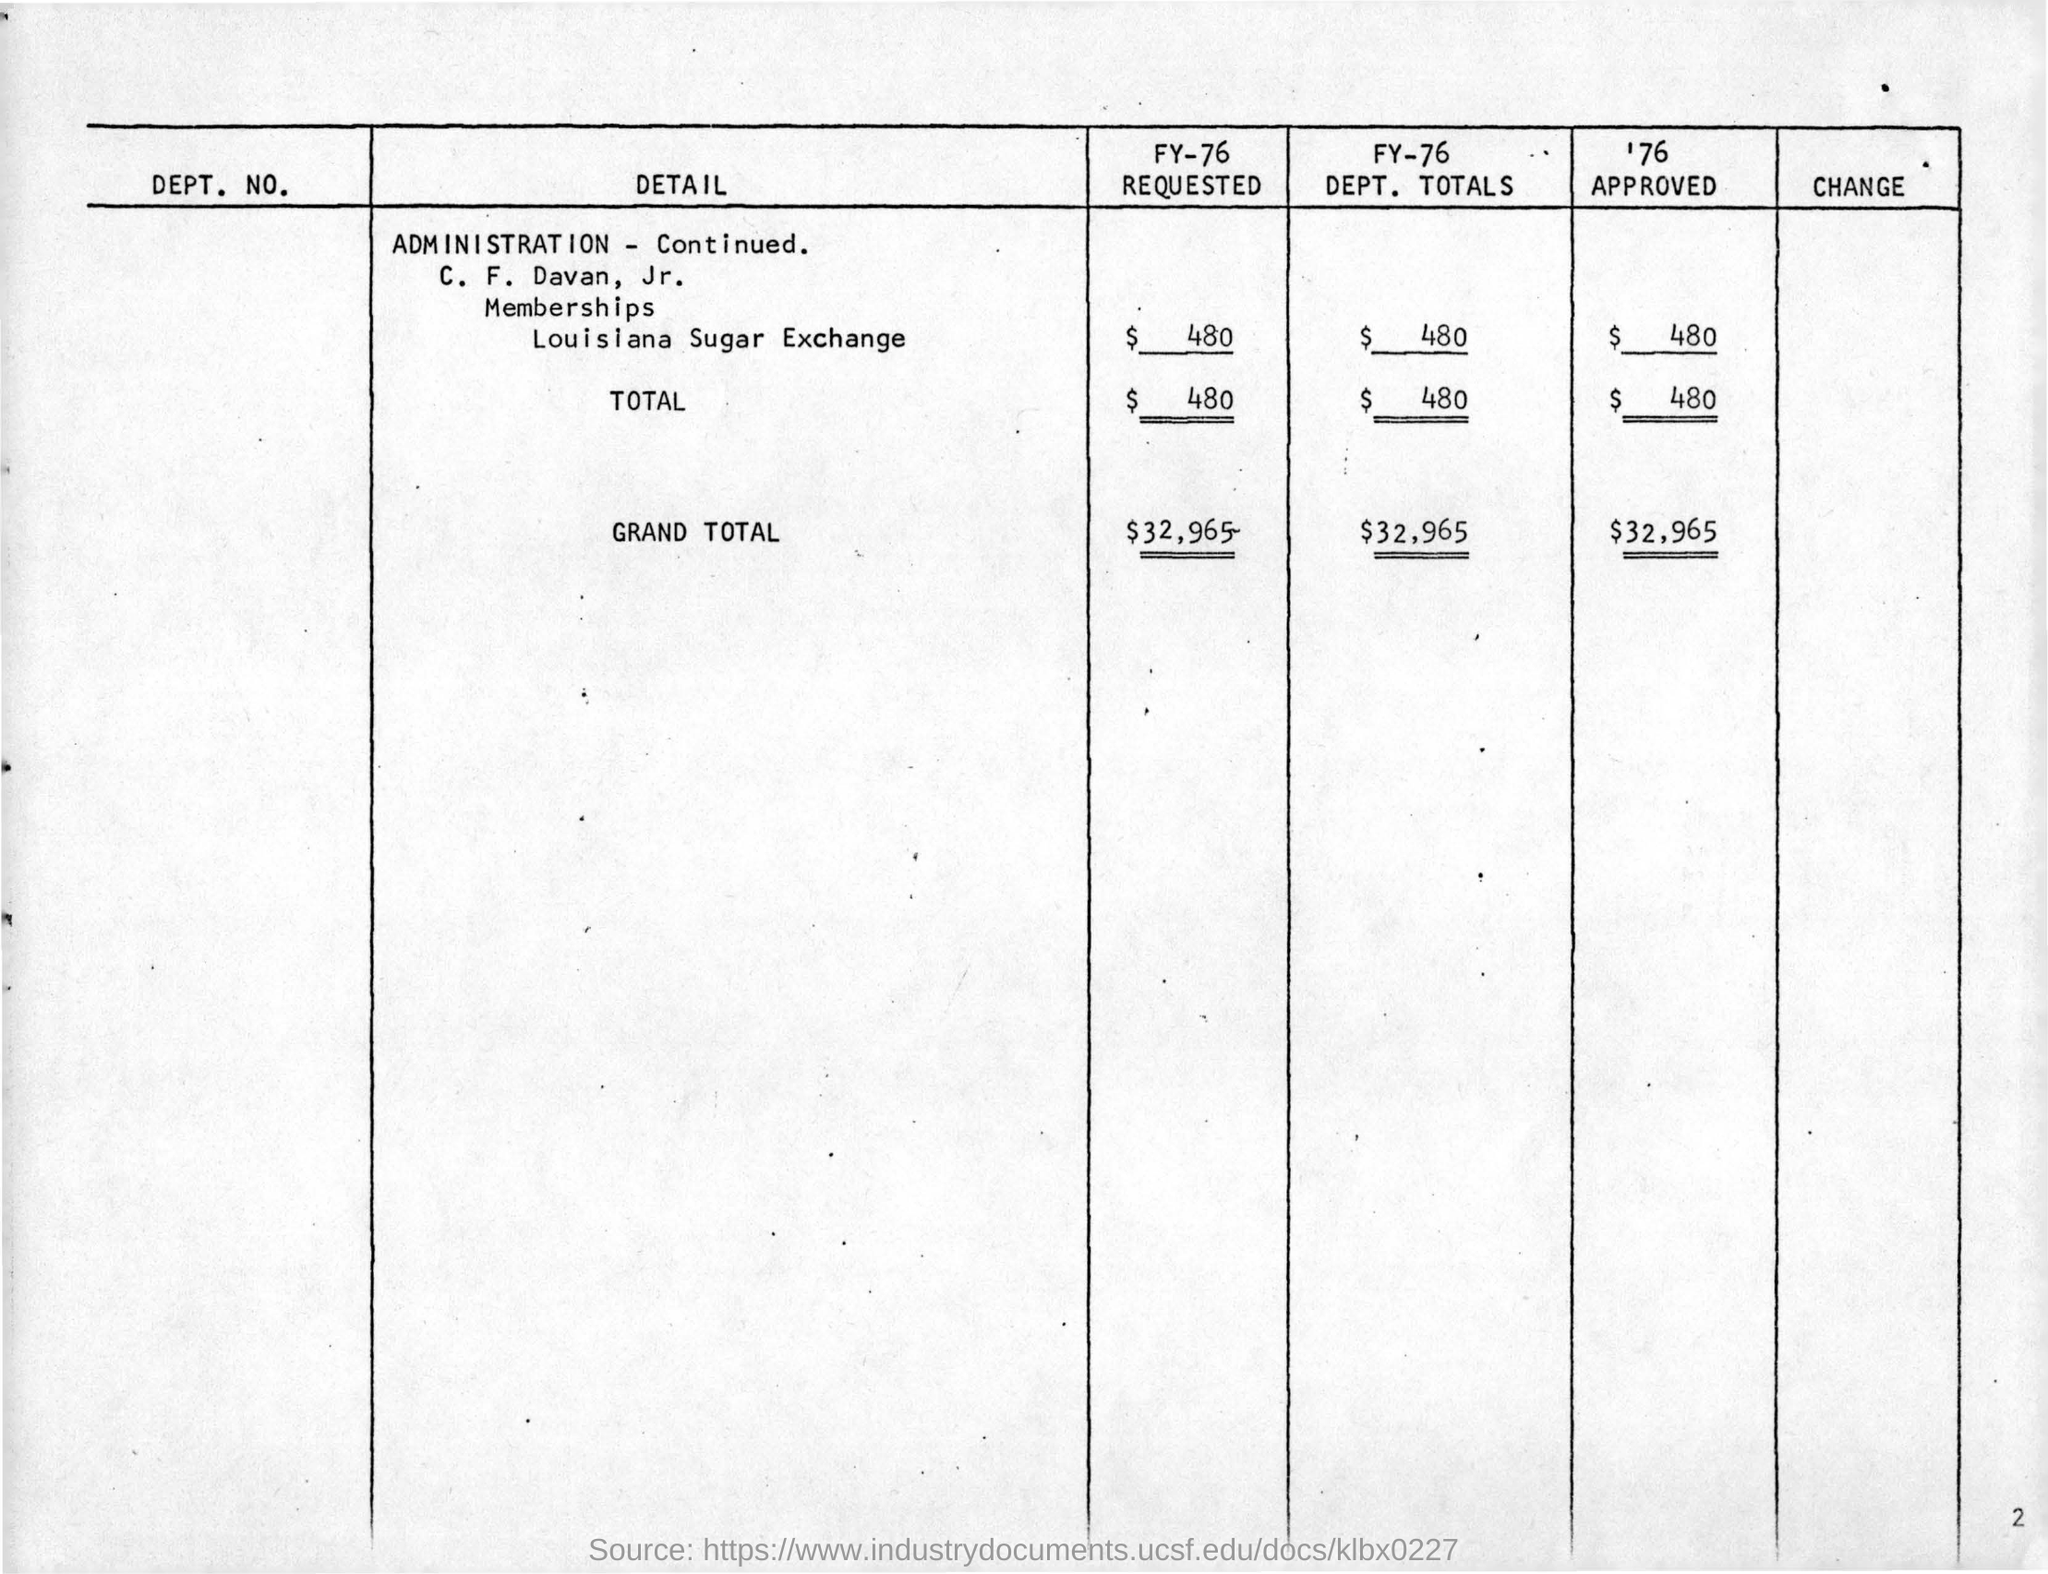Specify some key components in this picture. The page number is 2. 